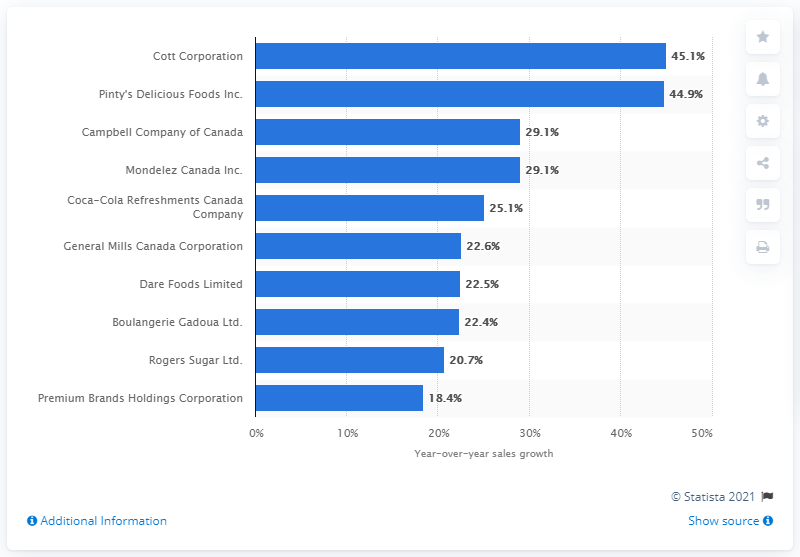What was the sales growth of Cott Corporation in 2017? In 2017, Cott Corporation achieved an impressive sales growth of 45.1%, topping the chart and showcasing a notable performance in their sector. 